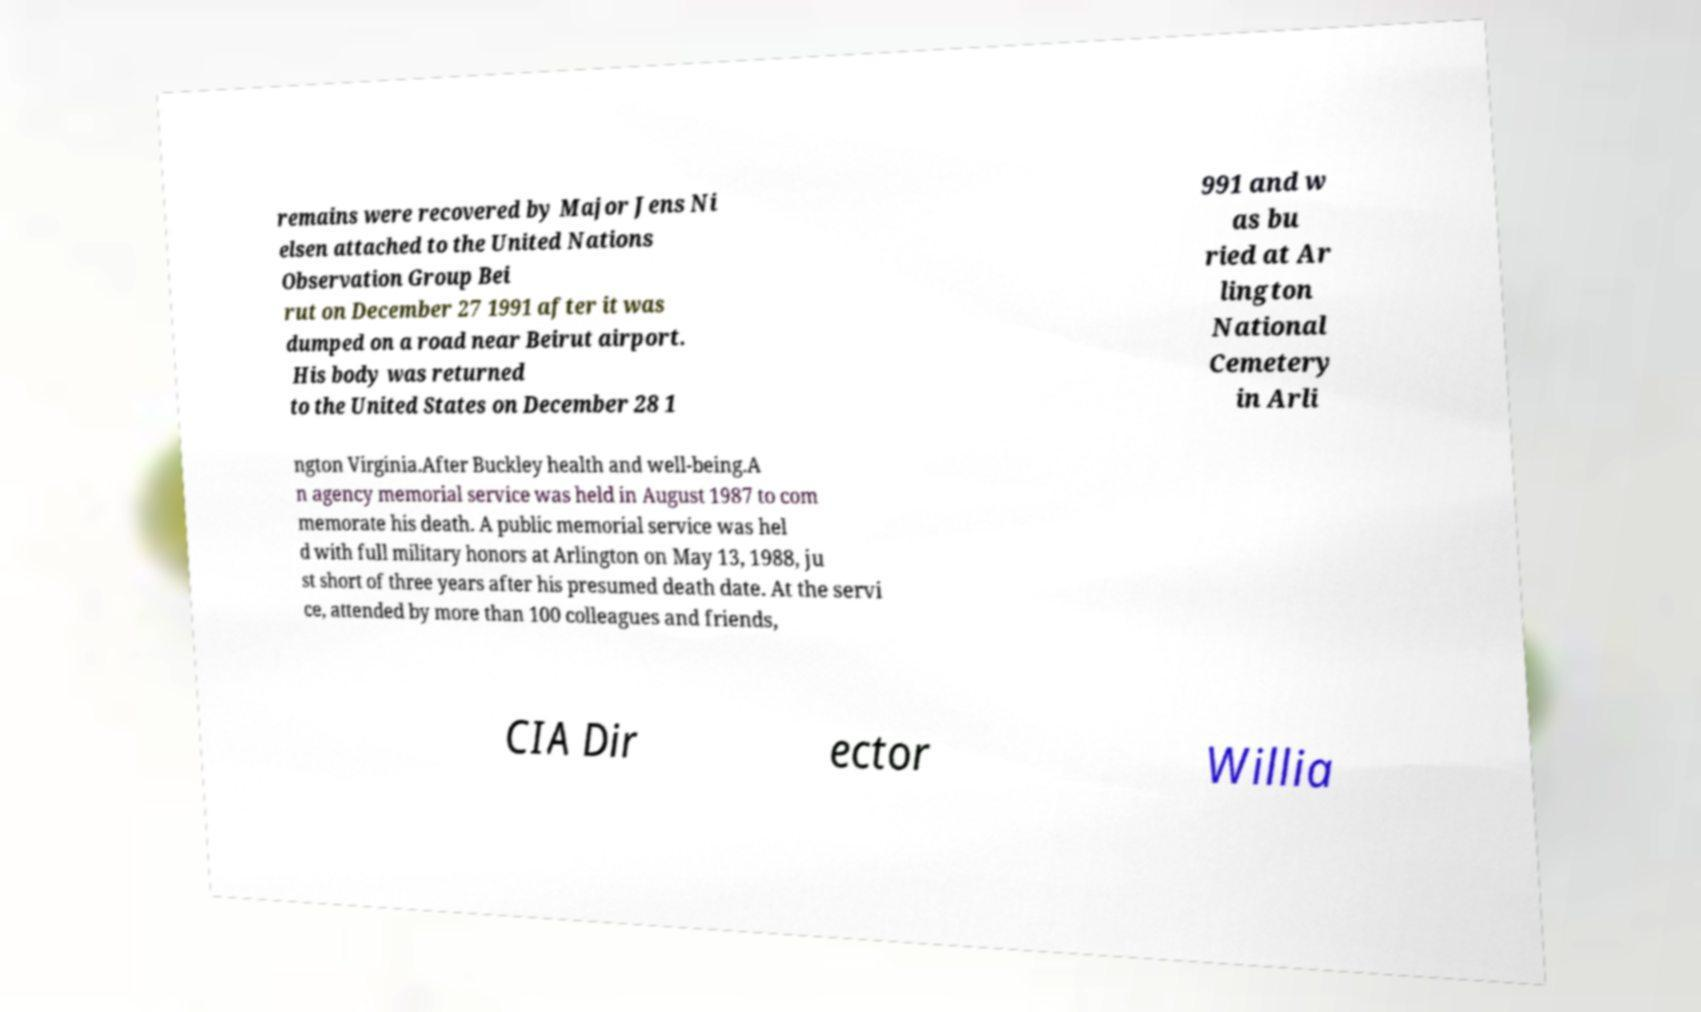Could you extract and type out the text from this image? remains were recovered by Major Jens Ni elsen attached to the United Nations Observation Group Bei rut on December 27 1991 after it was dumped on a road near Beirut airport. His body was returned to the United States on December 28 1 991 and w as bu ried at Ar lington National Cemetery in Arli ngton Virginia.After Buckley health and well-being.A n agency memorial service was held in August 1987 to com memorate his death. A public memorial service was hel d with full military honors at Arlington on May 13, 1988, ju st short of three years after his presumed death date. At the servi ce, attended by more than 100 colleagues and friends, CIA Dir ector Willia 